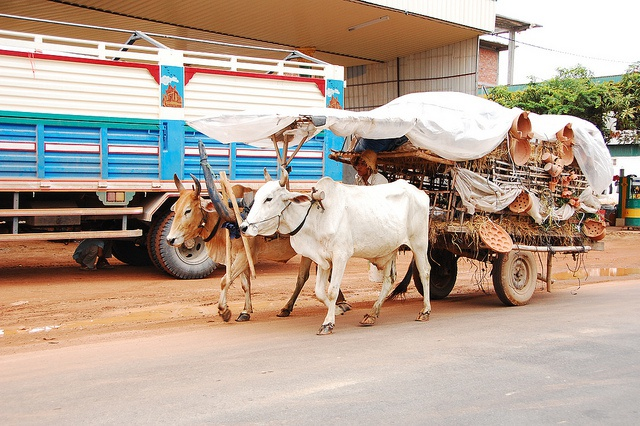Describe the objects in this image and their specific colors. I can see truck in brown, white, black, and lightblue tones, cow in brown, lightgray, and tan tones, cow in brown, tan, and maroon tones, people in brown, black, maroon, and gray tones, and people in brown, maroon, black, and tan tones in this image. 